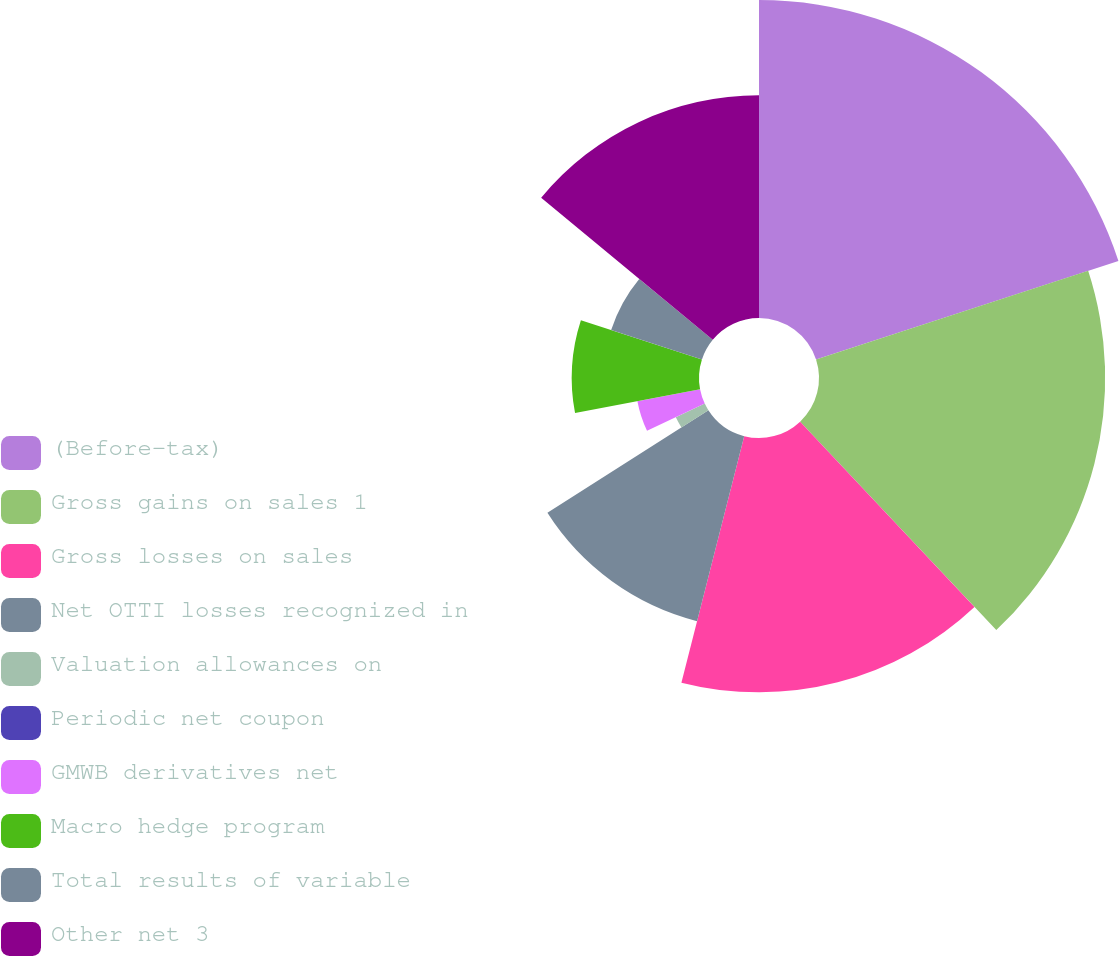Convert chart to OTSL. <chart><loc_0><loc_0><loc_500><loc_500><pie_chart><fcel>(Before-tax)<fcel>Gross gains on sales 1<fcel>Gross losses on sales<fcel>Net OTTI losses recognized in<fcel>Valuation allowances on<fcel>Periodic net coupon<fcel>GMWB derivatives net<fcel>Macro hedge program<fcel>Total results of variable<fcel>Other net 3<nl><fcel>19.99%<fcel>17.99%<fcel>15.99%<fcel>12.0%<fcel>2.01%<fcel>0.01%<fcel>4.01%<fcel>8.0%<fcel>6.0%<fcel>14.0%<nl></chart> 